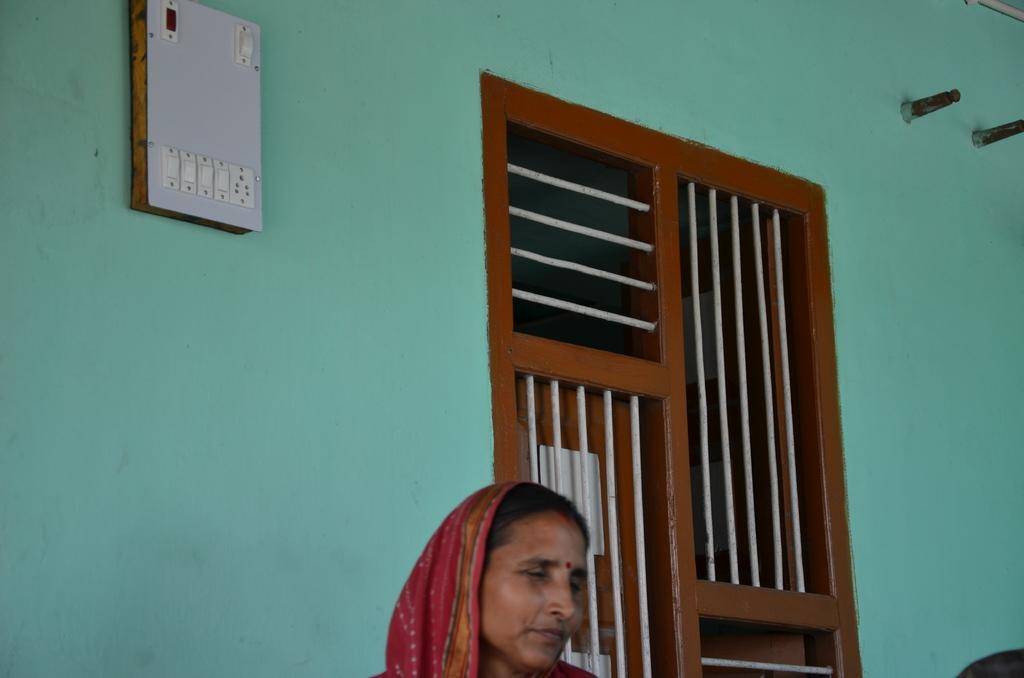Who is present in the image? There is a woman in the image. What can be seen in the center of the image? There is a window in the image. Where is the switch board located in the image? The switch board is on the left side of the image. What is on the left side of the image besides the switch board? There is a wall on the left side of the image. Where are the bolts located in the image? The bolts are on the right side of the image. What is the plot of the science fiction story taking place in the image? There is no science fiction story or plot present in the image; it features a woman, a window, a switch board, a wall, and bolts. 